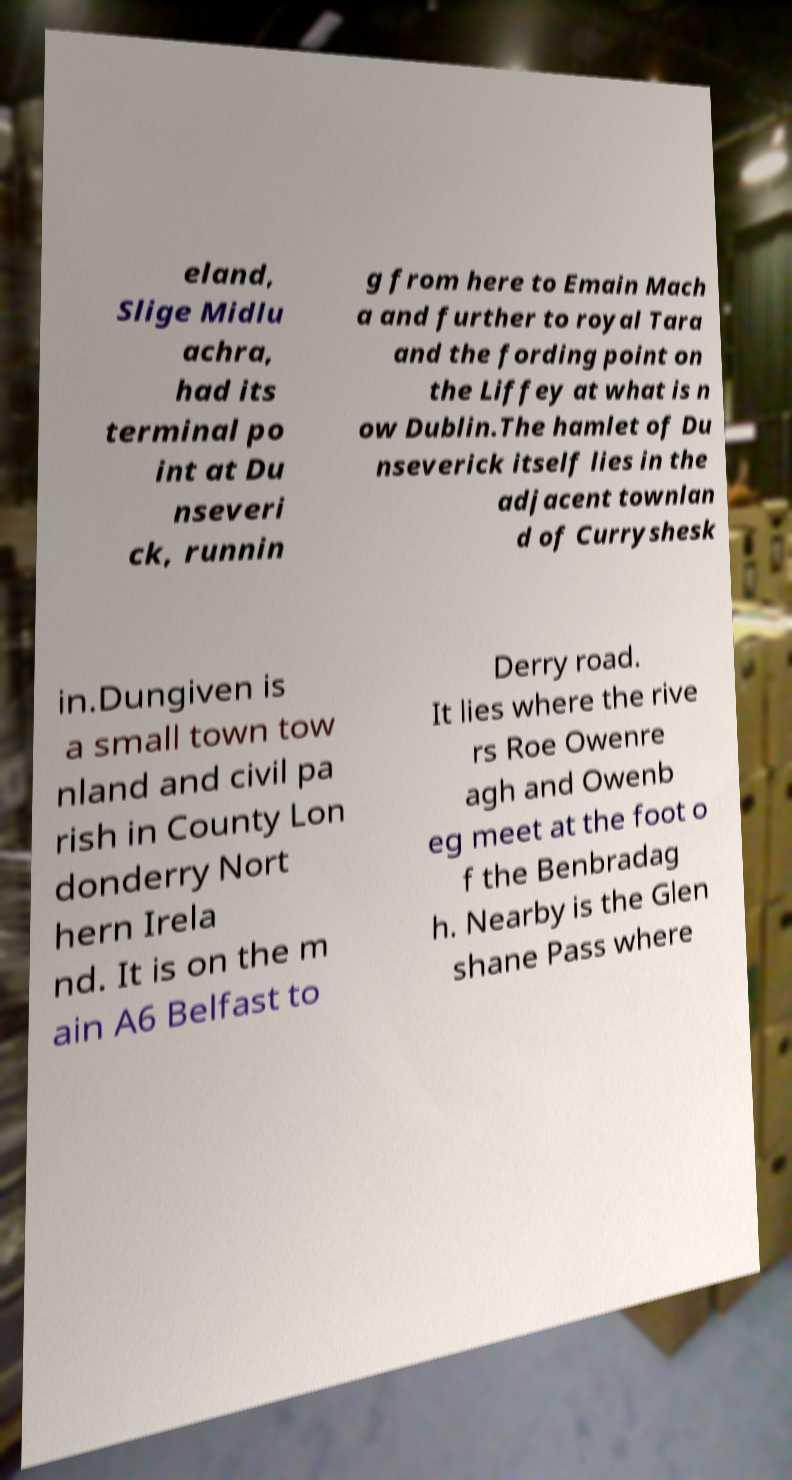What messages or text are displayed in this image? I need them in a readable, typed format. eland, Slige Midlu achra, had its terminal po int at Du nseveri ck, runnin g from here to Emain Mach a and further to royal Tara and the fording point on the Liffey at what is n ow Dublin.The hamlet of Du nseverick itself lies in the adjacent townlan d of Curryshesk in.Dungiven is a small town tow nland and civil pa rish in County Lon donderry Nort hern Irela nd. It is on the m ain A6 Belfast to Derry road. It lies where the rive rs Roe Owenre agh and Owenb eg meet at the foot o f the Benbradag h. Nearby is the Glen shane Pass where 